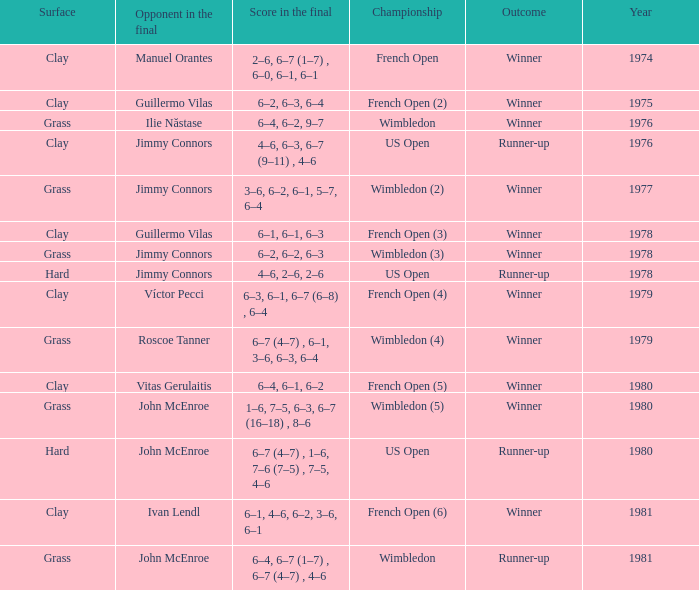What is every score in the final for opponent in final John Mcenroe at US Open? 6–7 (4–7) , 1–6, 7–6 (7–5) , 7–5, 4–6. 